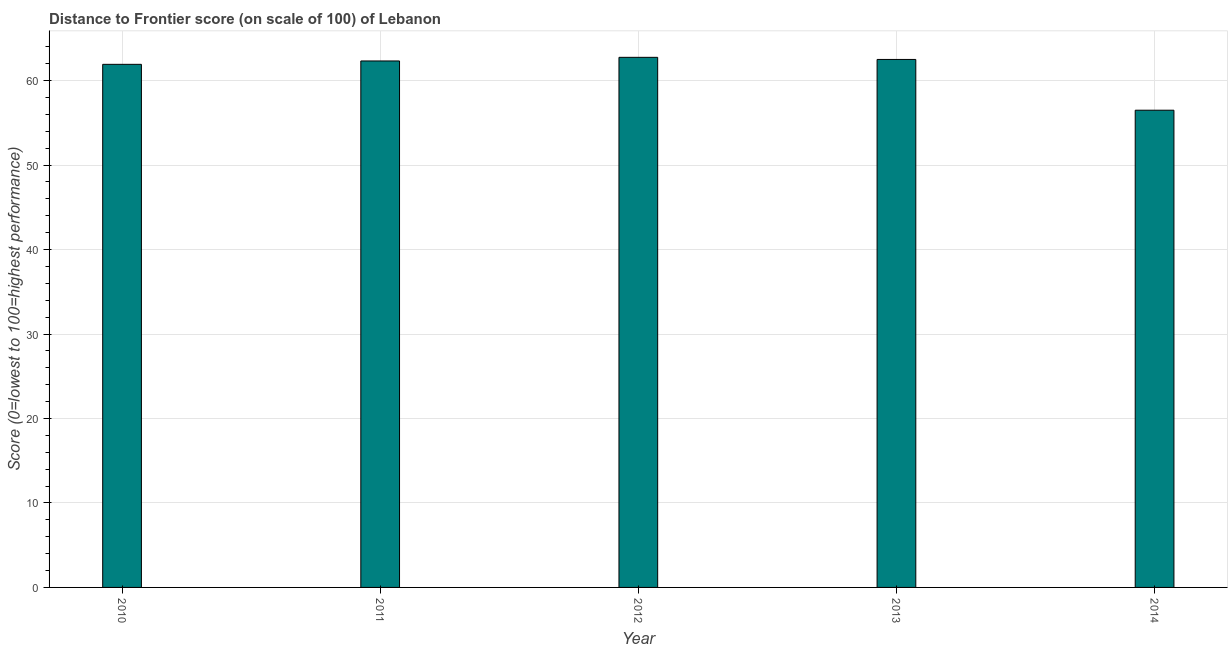Does the graph contain any zero values?
Make the answer very short. No. What is the title of the graph?
Give a very brief answer. Distance to Frontier score (on scale of 100) of Lebanon. What is the label or title of the Y-axis?
Your answer should be compact. Score (0=lowest to 100=highest performance). What is the distance to frontier score in 2013?
Offer a very short reply. 62.51. Across all years, what is the maximum distance to frontier score?
Provide a short and direct response. 62.76. Across all years, what is the minimum distance to frontier score?
Make the answer very short. 56.5. In which year was the distance to frontier score minimum?
Make the answer very short. 2014. What is the sum of the distance to frontier score?
Keep it short and to the point. 306.03. What is the difference between the distance to frontier score in 2011 and 2014?
Keep it short and to the point. 5.83. What is the average distance to frontier score per year?
Your response must be concise. 61.21. What is the median distance to frontier score?
Your response must be concise. 62.33. In how many years, is the distance to frontier score greater than 10 ?
Provide a succinct answer. 5. What is the ratio of the distance to frontier score in 2010 to that in 2012?
Make the answer very short. 0.99. Is the distance to frontier score in 2011 less than that in 2013?
Provide a short and direct response. Yes. What is the difference between the highest and the second highest distance to frontier score?
Your response must be concise. 0.25. Is the sum of the distance to frontier score in 2013 and 2014 greater than the maximum distance to frontier score across all years?
Give a very brief answer. Yes. What is the difference between the highest and the lowest distance to frontier score?
Offer a terse response. 6.26. In how many years, is the distance to frontier score greater than the average distance to frontier score taken over all years?
Your response must be concise. 4. How many years are there in the graph?
Ensure brevity in your answer.  5. What is the Score (0=lowest to 100=highest performance) of 2010?
Keep it short and to the point. 61.93. What is the Score (0=lowest to 100=highest performance) in 2011?
Make the answer very short. 62.33. What is the Score (0=lowest to 100=highest performance) of 2012?
Your answer should be compact. 62.76. What is the Score (0=lowest to 100=highest performance) in 2013?
Offer a terse response. 62.51. What is the Score (0=lowest to 100=highest performance) of 2014?
Offer a terse response. 56.5. What is the difference between the Score (0=lowest to 100=highest performance) in 2010 and 2012?
Provide a succinct answer. -0.83. What is the difference between the Score (0=lowest to 100=highest performance) in 2010 and 2013?
Provide a short and direct response. -0.58. What is the difference between the Score (0=lowest to 100=highest performance) in 2010 and 2014?
Provide a succinct answer. 5.43. What is the difference between the Score (0=lowest to 100=highest performance) in 2011 and 2012?
Your response must be concise. -0.43. What is the difference between the Score (0=lowest to 100=highest performance) in 2011 and 2013?
Your answer should be compact. -0.18. What is the difference between the Score (0=lowest to 100=highest performance) in 2011 and 2014?
Your answer should be very brief. 5.83. What is the difference between the Score (0=lowest to 100=highest performance) in 2012 and 2013?
Your response must be concise. 0.25. What is the difference between the Score (0=lowest to 100=highest performance) in 2012 and 2014?
Provide a succinct answer. 6.26. What is the difference between the Score (0=lowest to 100=highest performance) in 2013 and 2014?
Provide a succinct answer. 6.01. What is the ratio of the Score (0=lowest to 100=highest performance) in 2010 to that in 2012?
Ensure brevity in your answer.  0.99. What is the ratio of the Score (0=lowest to 100=highest performance) in 2010 to that in 2014?
Your answer should be compact. 1.1. What is the ratio of the Score (0=lowest to 100=highest performance) in 2011 to that in 2012?
Provide a succinct answer. 0.99. What is the ratio of the Score (0=lowest to 100=highest performance) in 2011 to that in 2013?
Offer a very short reply. 1. What is the ratio of the Score (0=lowest to 100=highest performance) in 2011 to that in 2014?
Ensure brevity in your answer.  1.1. What is the ratio of the Score (0=lowest to 100=highest performance) in 2012 to that in 2014?
Make the answer very short. 1.11. What is the ratio of the Score (0=lowest to 100=highest performance) in 2013 to that in 2014?
Offer a terse response. 1.11. 